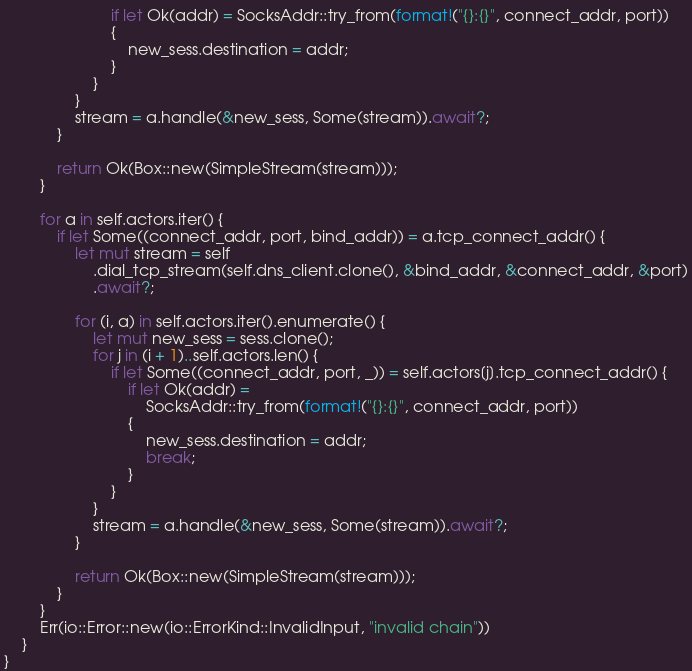<code> <loc_0><loc_0><loc_500><loc_500><_Rust_>                        if let Ok(addr) = SocksAddr::try_from(format!("{}:{}", connect_addr, port))
                        {
                            new_sess.destination = addr;
                        }
                    }
                }
                stream = a.handle(&new_sess, Some(stream)).await?;
            }

            return Ok(Box::new(SimpleStream(stream)));
        }

        for a in self.actors.iter() {
            if let Some((connect_addr, port, bind_addr)) = a.tcp_connect_addr() {
                let mut stream = self
                    .dial_tcp_stream(self.dns_client.clone(), &bind_addr, &connect_addr, &port)
                    .await?;

                for (i, a) in self.actors.iter().enumerate() {
                    let mut new_sess = sess.clone();
                    for j in (i + 1)..self.actors.len() {
                        if let Some((connect_addr, port, _)) = self.actors[j].tcp_connect_addr() {
                            if let Ok(addr) =
                                SocksAddr::try_from(format!("{}:{}", connect_addr, port))
                            {
                                new_sess.destination = addr;
                                break;
                            }
                        }
                    }
                    stream = a.handle(&new_sess, Some(stream)).await?;
                }

                return Ok(Box::new(SimpleStream(stream)));
            }
        }
        Err(io::Error::new(io::ErrorKind::InvalidInput, "invalid chain"))
    }
}
</code> 